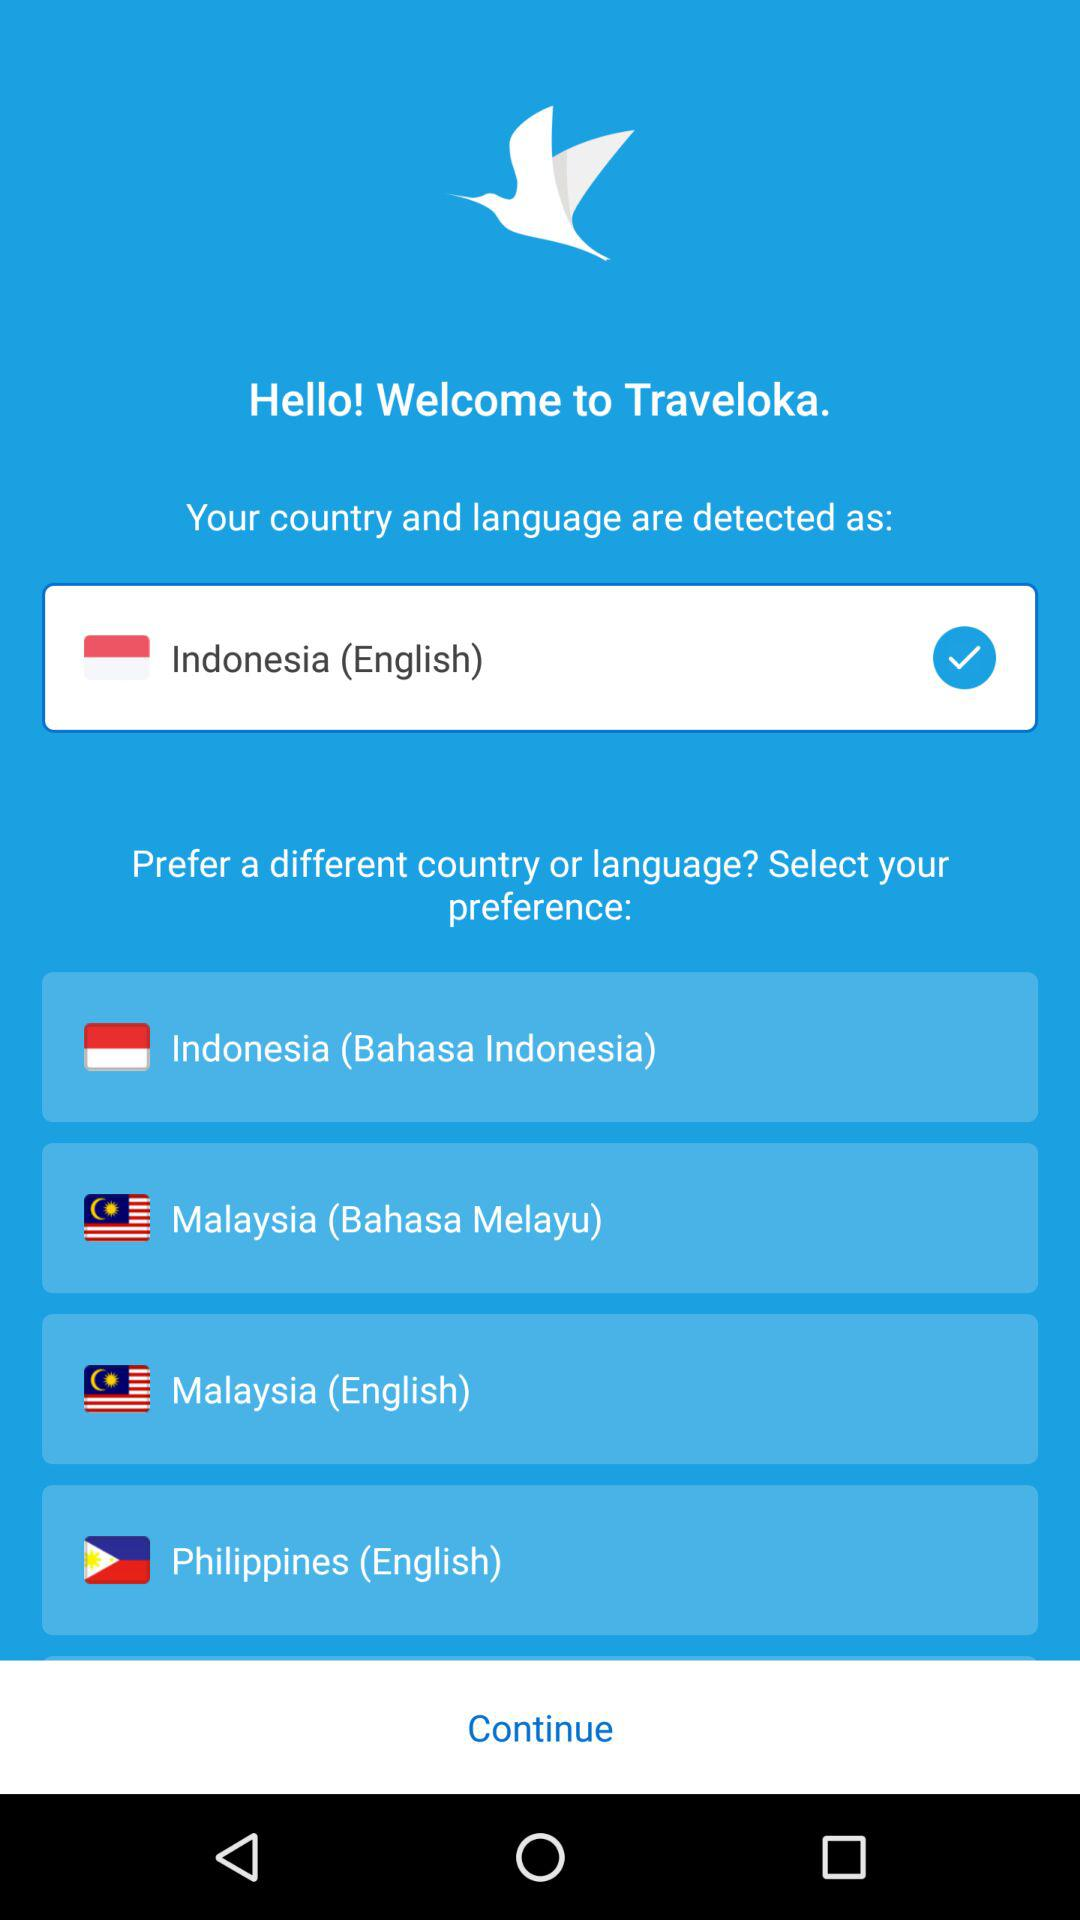How many languages are available in the language selection menu?
Answer the question using a single word or phrase. 4 